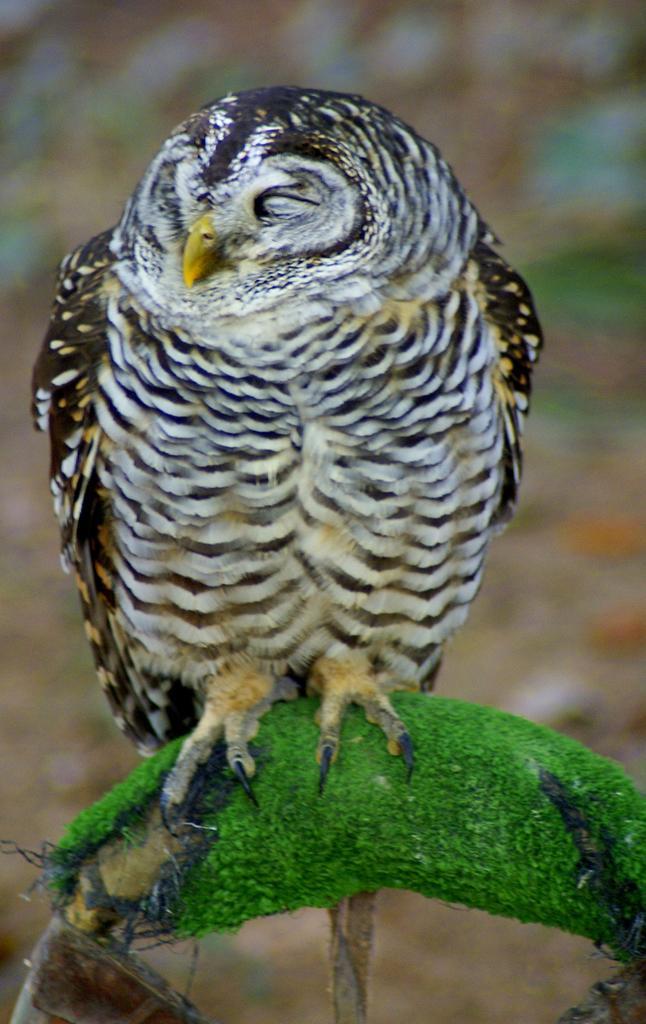Could you give a brief overview of what you see in this image? In the picture we can see an owl on the stem and the background is not clear. 